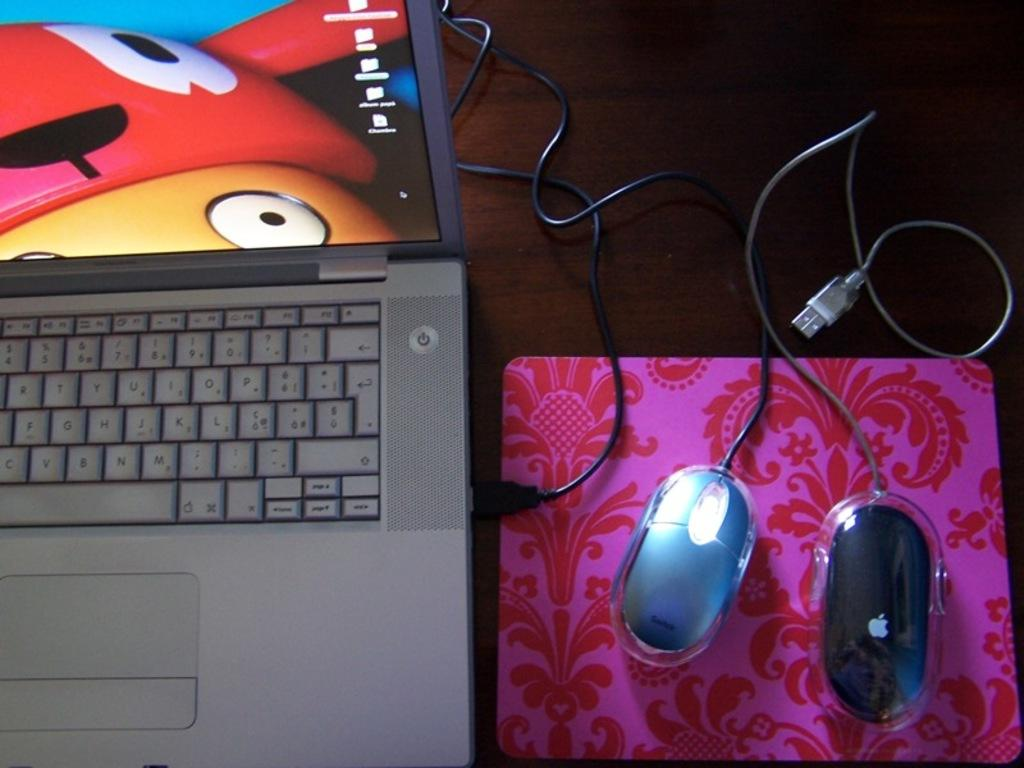What animals are on the mouse pad in the image? There are two mice on the mouse pad. What electronic device is on the table in the image? There is a laptop on the table. What type of heart-shaped object can be seen on the laptop in the image? There is no heart-shaped object present on the laptop in the image. Is there a crook in the image, and if so, where is it located? There is no crook present in the image. How many rings are visible on the mice in the image? The mice in the image do not have rings on them. 